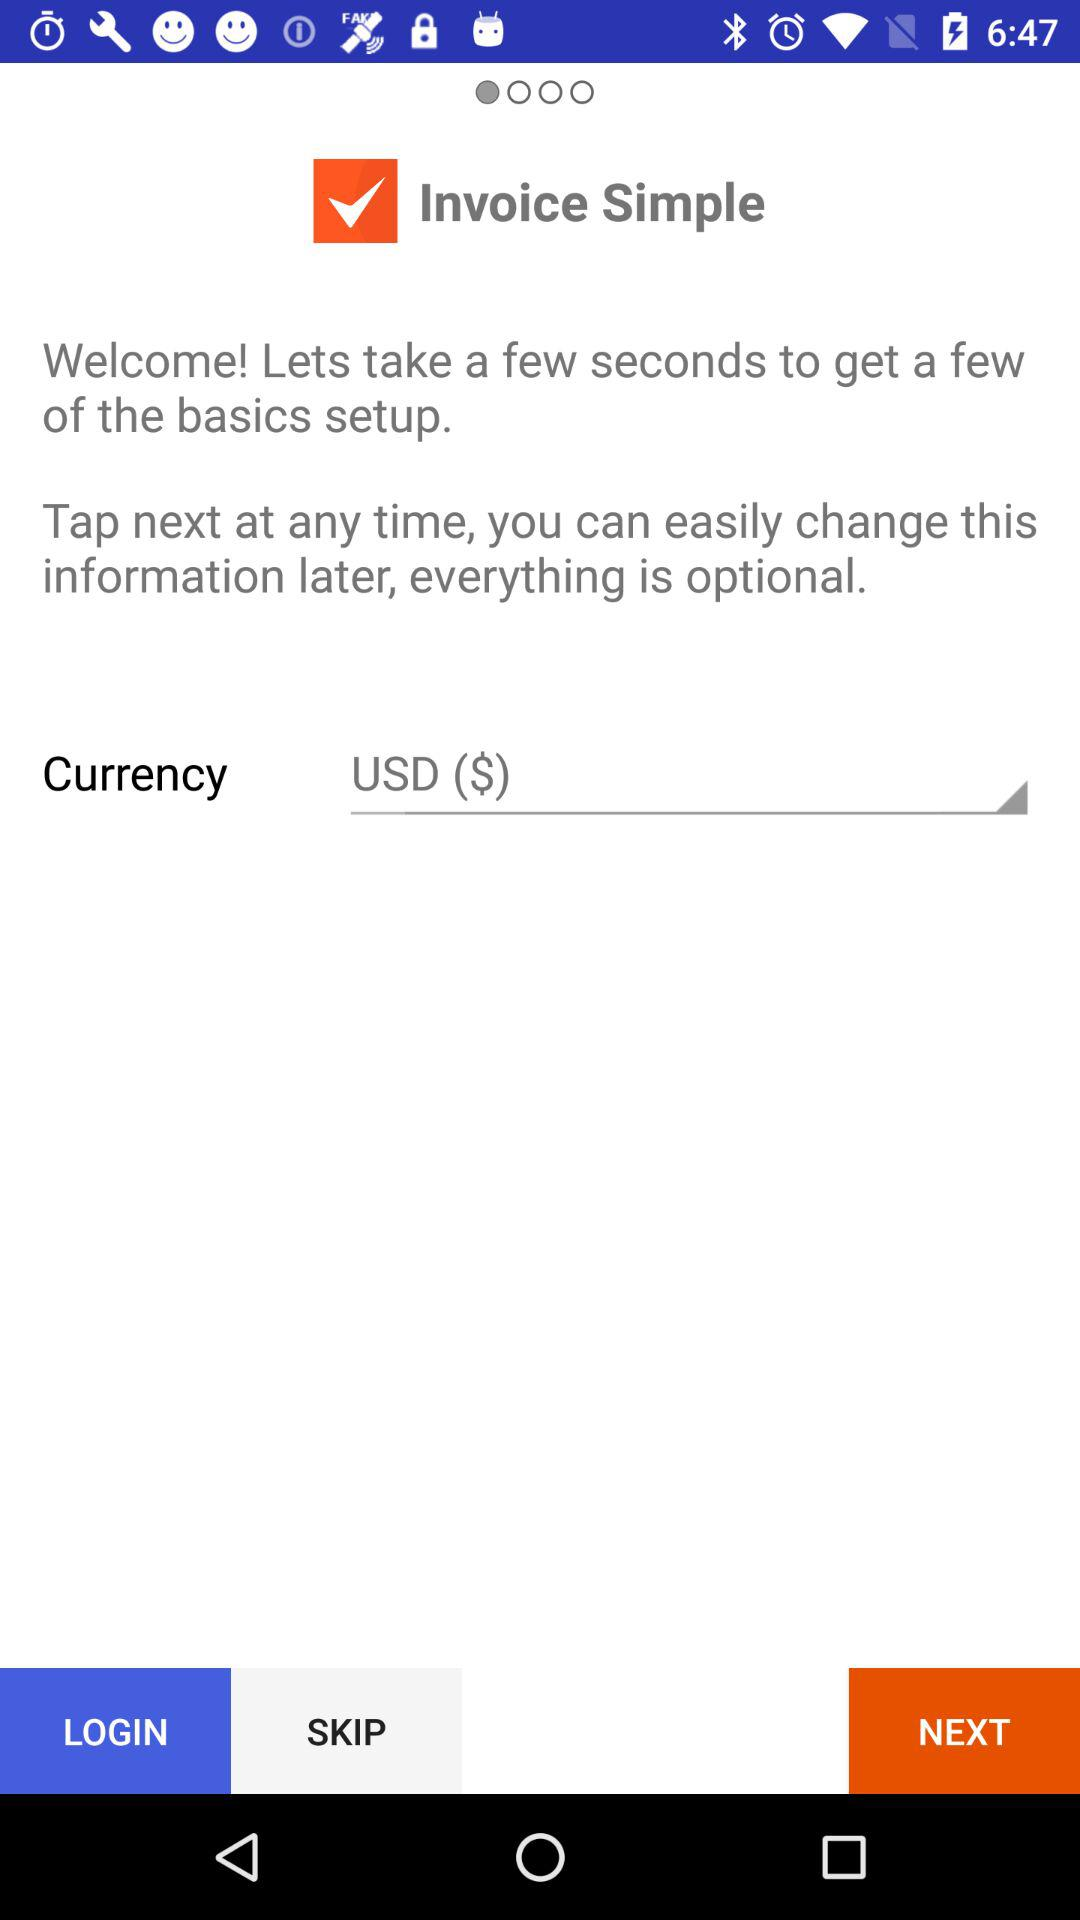What is the currency mentioned? The currency is "USD ($)". 